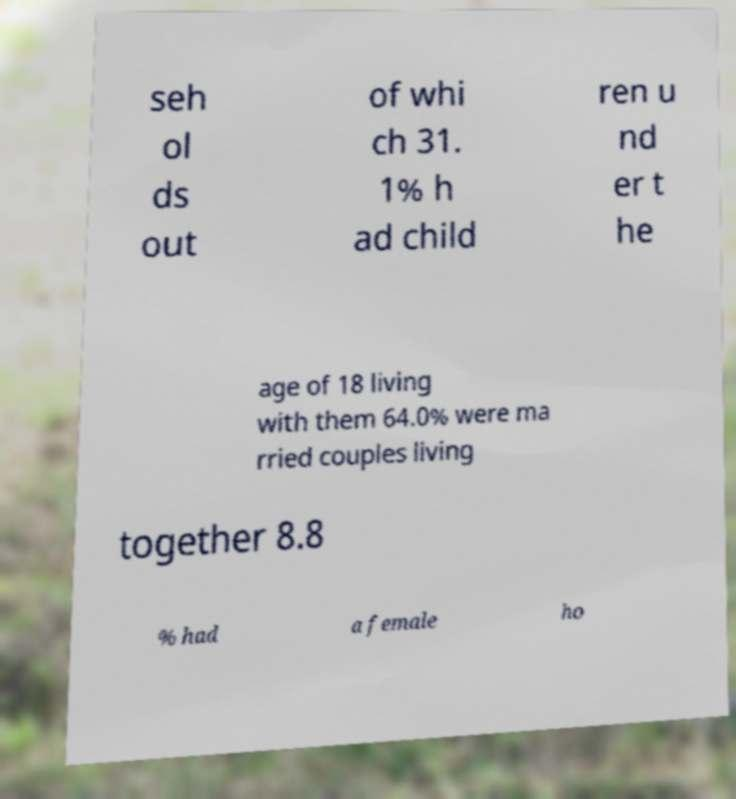Please read and relay the text visible in this image. What does it say? seh ol ds out of whi ch 31. 1% h ad child ren u nd er t he age of 18 living with them 64.0% were ma rried couples living together 8.8 % had a female ho 